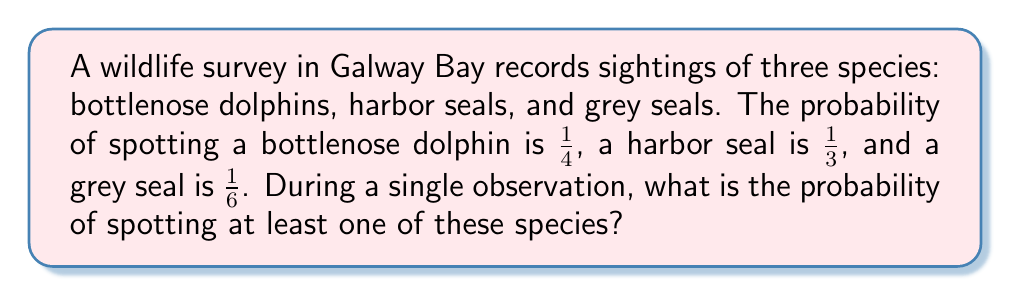Can you answer this question? Let's approach this step-by-step using the principle of inclusion-exclusion:

1) First, let's define our events:
   D: Spotting a bottlenose dolphin
   H: Spotting a harbor seal
   G: Spotting a grey seal

2) We want to find P(D ∪ H ∪ G), which is the probability of spotting at least one of these species.

3) The principle of inclusion-exclusion states:
   P(D ∪ H ∪ G) = P(D) + P(H) + P(G) - P(D ∩ H) - P(D ∩ G) - P(H ∩ G) + P(D ∩ H ∩ G)

4) We know:
   P(D) = $\frac{1}{4}$, P(H) = $\frac{1}{3}$, P(G) = $\frac{1}{6}$

5) Assuming the events are independent:
   P(D ∩ H) = P(D) × P(H) = $\frac{1}{4} × \frac{1}{3} = \frac{1}{12}$
   P(D ∩ G) = P(D) × P(G) = $\frac{1}{4} × \frac{1}{6} = \frac{1}{24}$
   P(H ∩ G) = P(H) × P(G) = $\frac{1}{3} × \frac{1}{6} = \frac{1}{18}$
   P(D ∩ H ∩ G) = P(D) × P(H) × P(G) = $\frac{1}{4} × \frac{1}{3} × \frac{1}{6} = \frac{1}{72}$

6) Now, let's substitute these values into our equation:
   P(D ∪ H ∪ G) = $\frac{1}{4} + \frac{1}{3} + \frac{1}{6} - \frac{1}{12} - \frac{1}{24} - \frac{1}{18} + \frac{1}{72}$

7) Finding a common denominator of 72:
   P(D ∪ H ∪ G) = $\frac{18}{72} + \frac{24}{72} + \frac{12}{72} - \frac{6}{72} - \frac{3}{72} - \frac{4}{72} + \frac{1}{72}$

8) Summing up:
   P(D ∪ H ∪ G) = $\frac{42}{72} = \frac{7}{12}$

Therefore, the probability of spotting at least one of these species during a single observation is $\frac{7}{12}$.
Answer: $\frac{7}{12}$ 